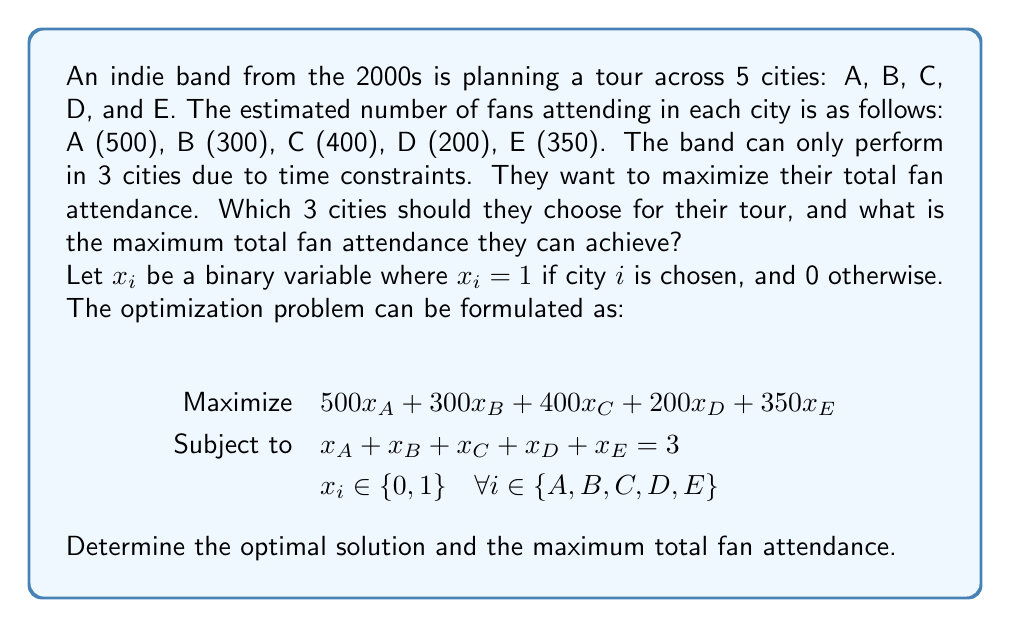Can you solve this math problem? To solve this problem, we'll use a greedy approach since the constraints allow us to simply choose the top 3 cities with the highest fan attendance.

Step 1: Order the cities by fan attendance from highest to lowest.
1. A: 500 fans
2. C: 400 fans
3. E: 350 fans
4. B: 300 fans
5. D: 200 fans

Step 2: Select the top 3 cities.
The optimal choice is to select cities A, C, and E.

Step 3: Calculate the total fan attendance.
Total attendance = Attendance in A + Attendance in C + Attendance in E
                 = 500 + 400 + 350
                 = 1250 fans

Therefore, the optimal solution is:
$$
x_A = 1, \quad x_C = 1, \quad x_E = 1, \quad x_B = 0, \quad x_D = 0
$$

This solution satisfies the constraint that only 3 cities are chosen:
$$
x_A + x_B + x_C + x_D + x_E = 1 + 0 + 1 + 0 + 1 = 3
$$

The maximum total fan attendance is 1250 fans.
Answer: The band should choose cities A, C, and E for their tour. The maximum total fan attendance they can achieve is 1250 fans. 